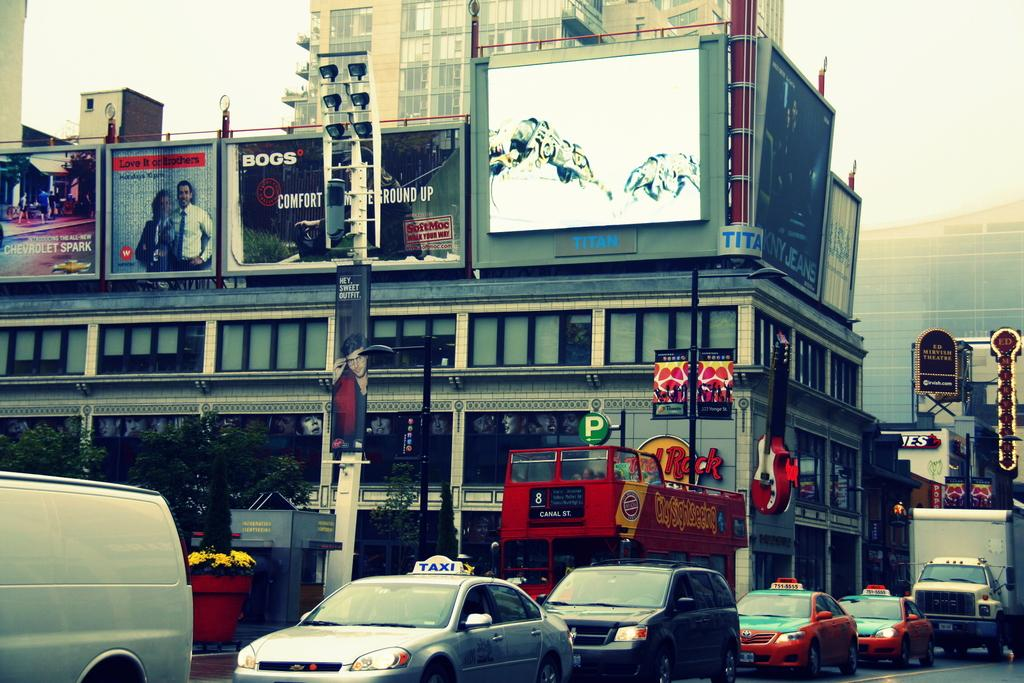<image>
Summarize the visual content of the image. the words round up are on the sign above the street 